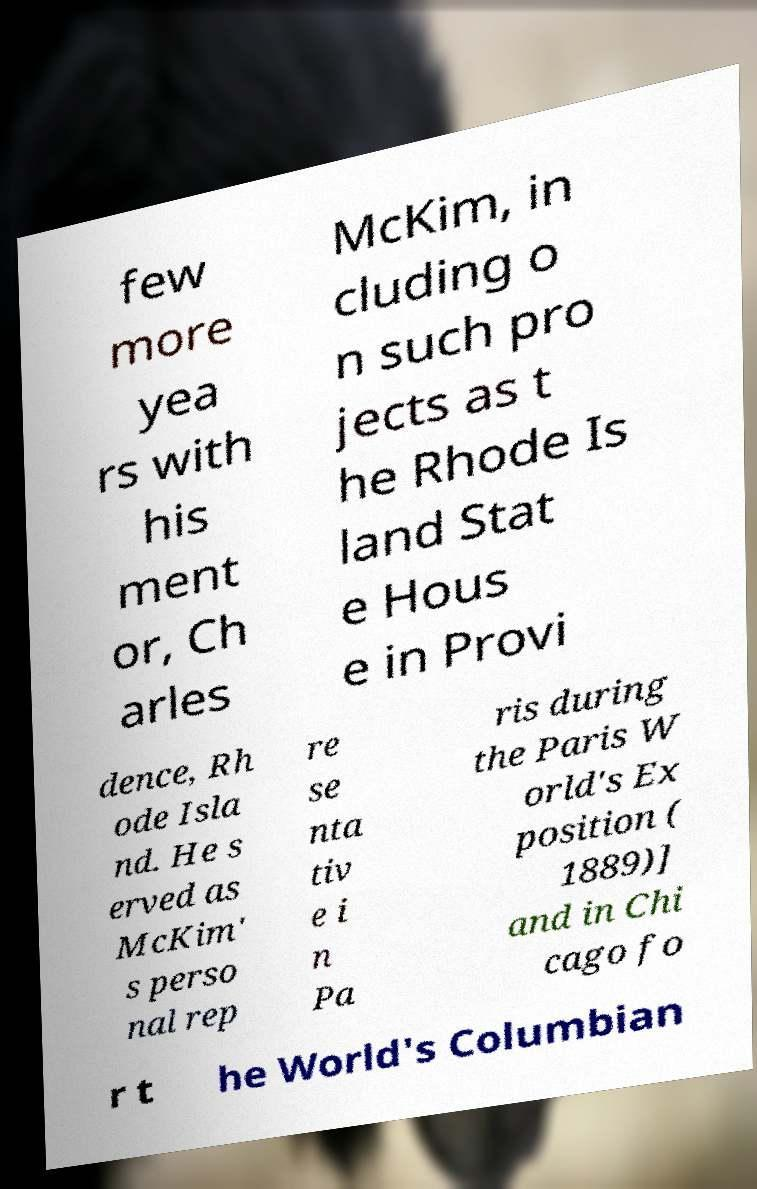What messages or text are displayed in this image? I need them in a readable, typed format. few more yea rs with his ment or, Ch arles McKim, in cluding o n such pro jects as t he Rhode Is land Stat e Hous e in Provi dence, Rh ode Isla nd. He s erved as McKim' s perso nal rep re se nta tiv e i n Pa ris during the Paris W orld's Ex position ( 1889)] and in Chi cago fo r t he World's Columbian 